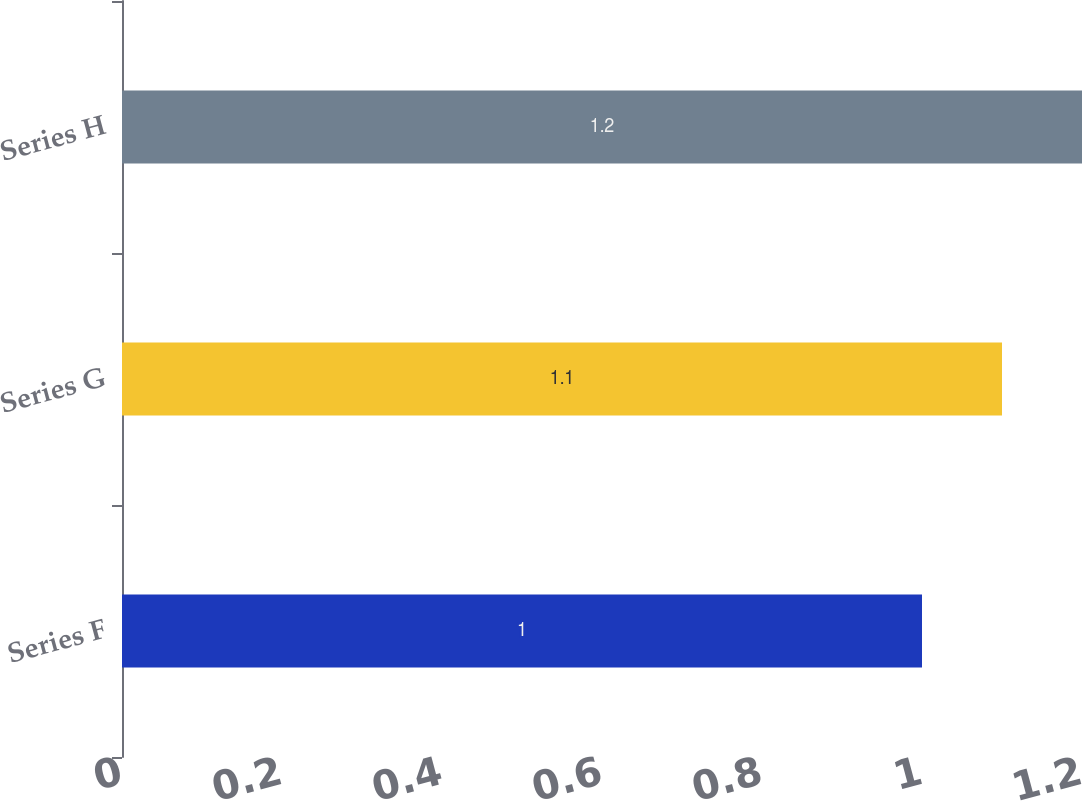Convert chart to OTSL. <chart><loc_0><loc_0><loc_500><loc_500><bar_chart><fcel>Series F<fcel>Series G<fcel>Series H<nl><fcel>1<fcel>1.1<fcel>1.2<nl></chart> 